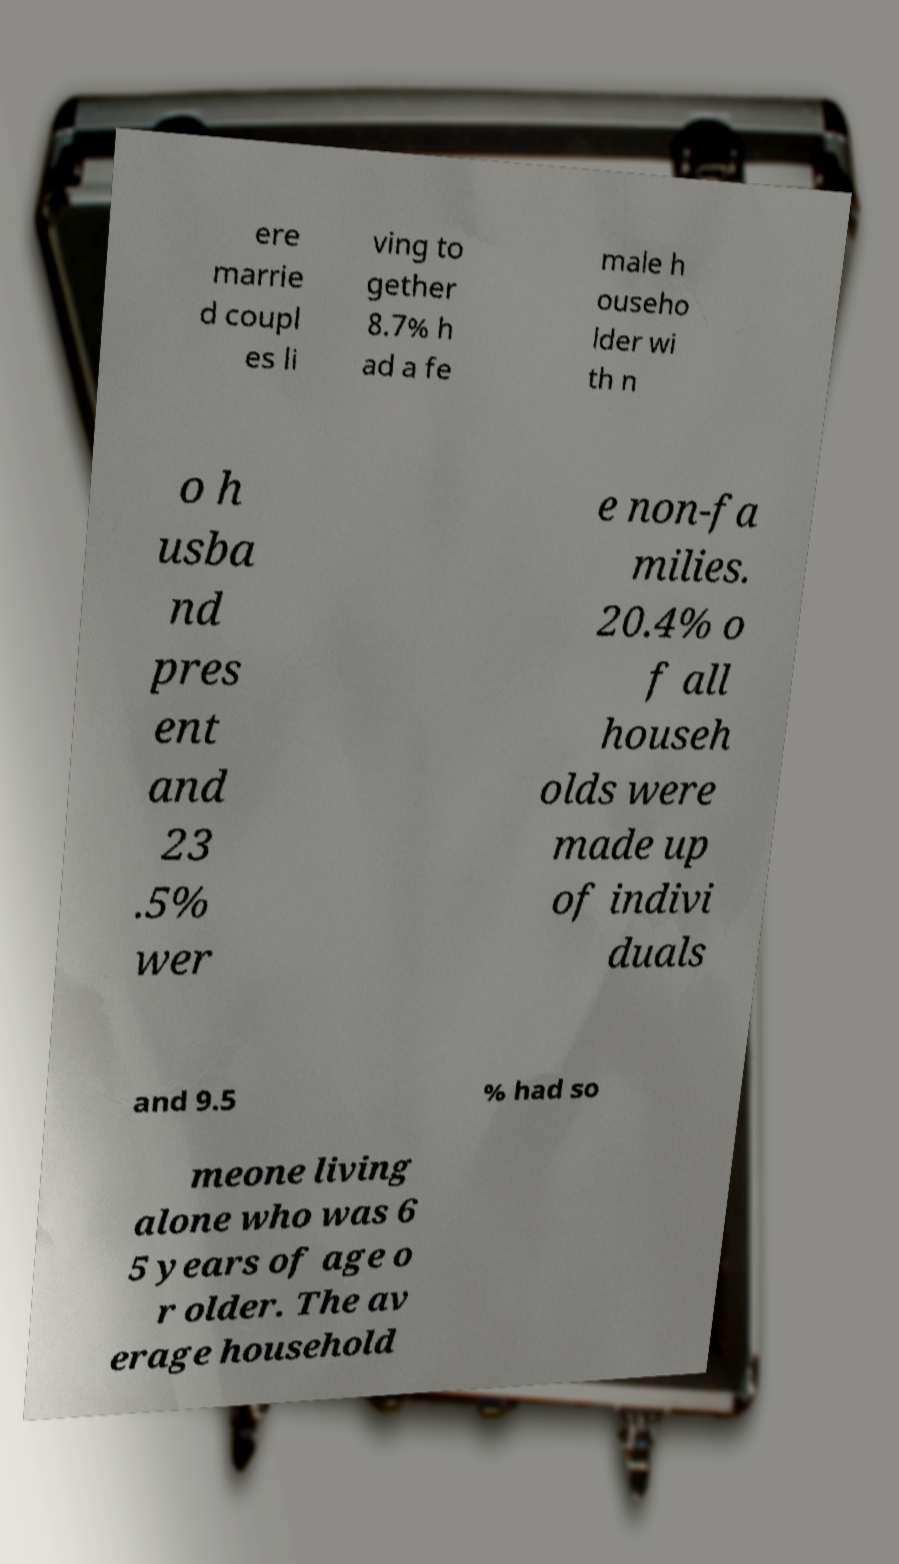For documentation purposes, I need the text within this image transcribed. Could you provide that? ere marrie d coupl es li ving to gether 8.7% h ad a fe male h ouseho lder wi th n o h usba nd pres ent and 23 .5% wer e non-fa milies. 20.4% o f all househ olds were made up of indivi duals and 9.5 % had so meone living alone who was 6 5 years of age o r older. The av erage household 